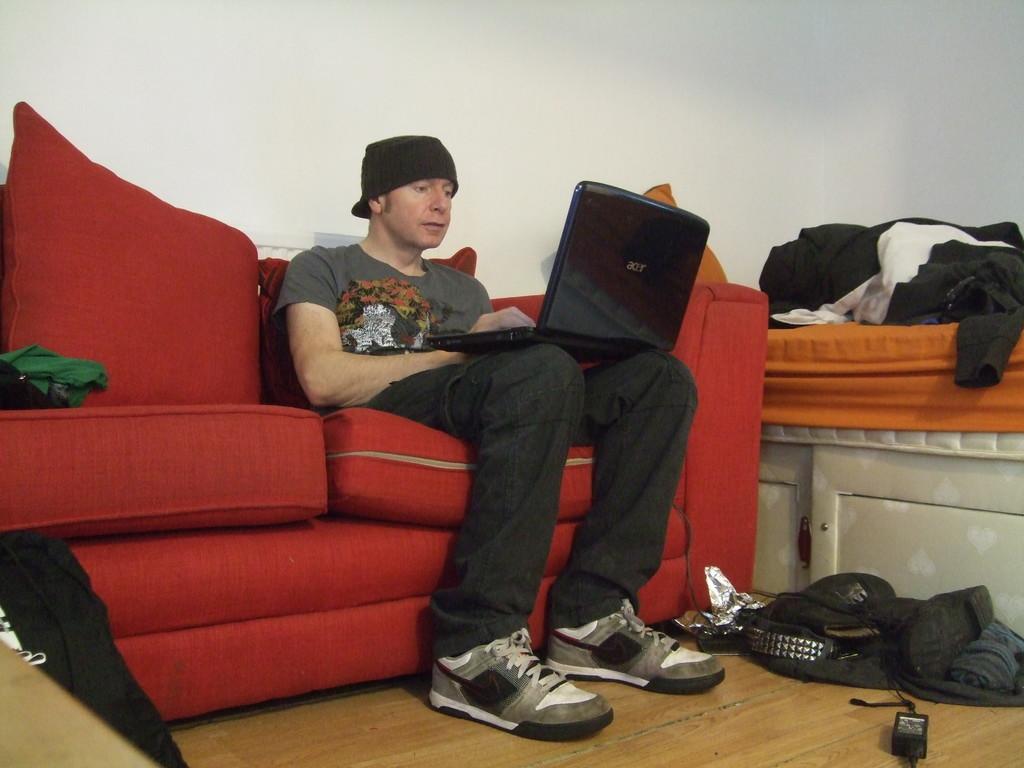Please provide a concise description of this image. In this image the person is sitting on the couch and he is holding the laptop. On the bed there are clothes. The couch is in red color. The person is wearing a hat. The bed is in orange color. The background is in white color. 